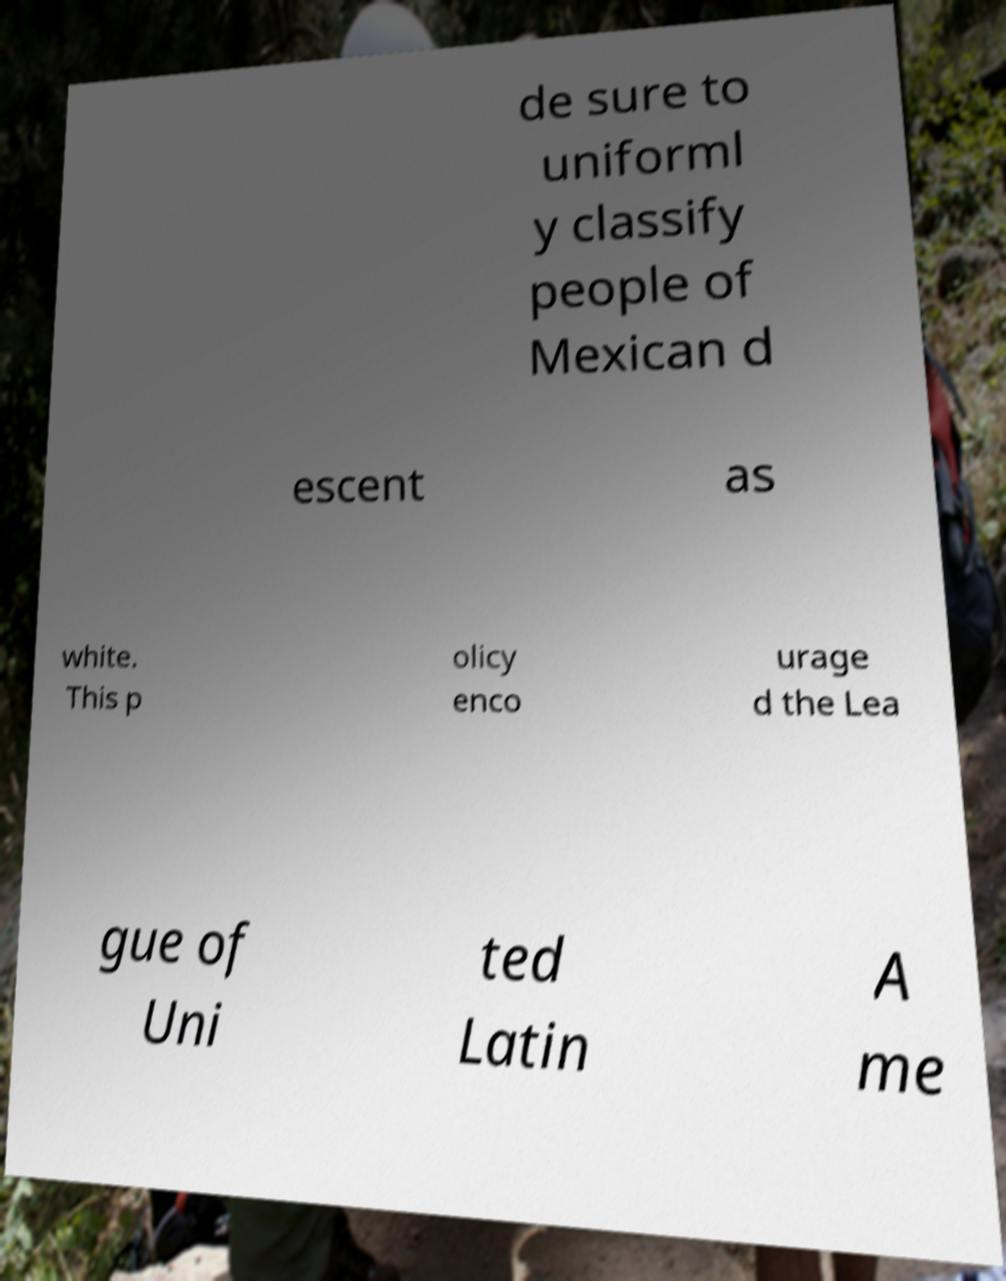Can you read and provide the text displayed in the image?This photo seems to have some interesting text. Can you extract and type it out for me? de sure to uniforml y classify people of Mexican d escent as white. This p olicy enco urage d the Lea gue of Uni ted Latin A me 